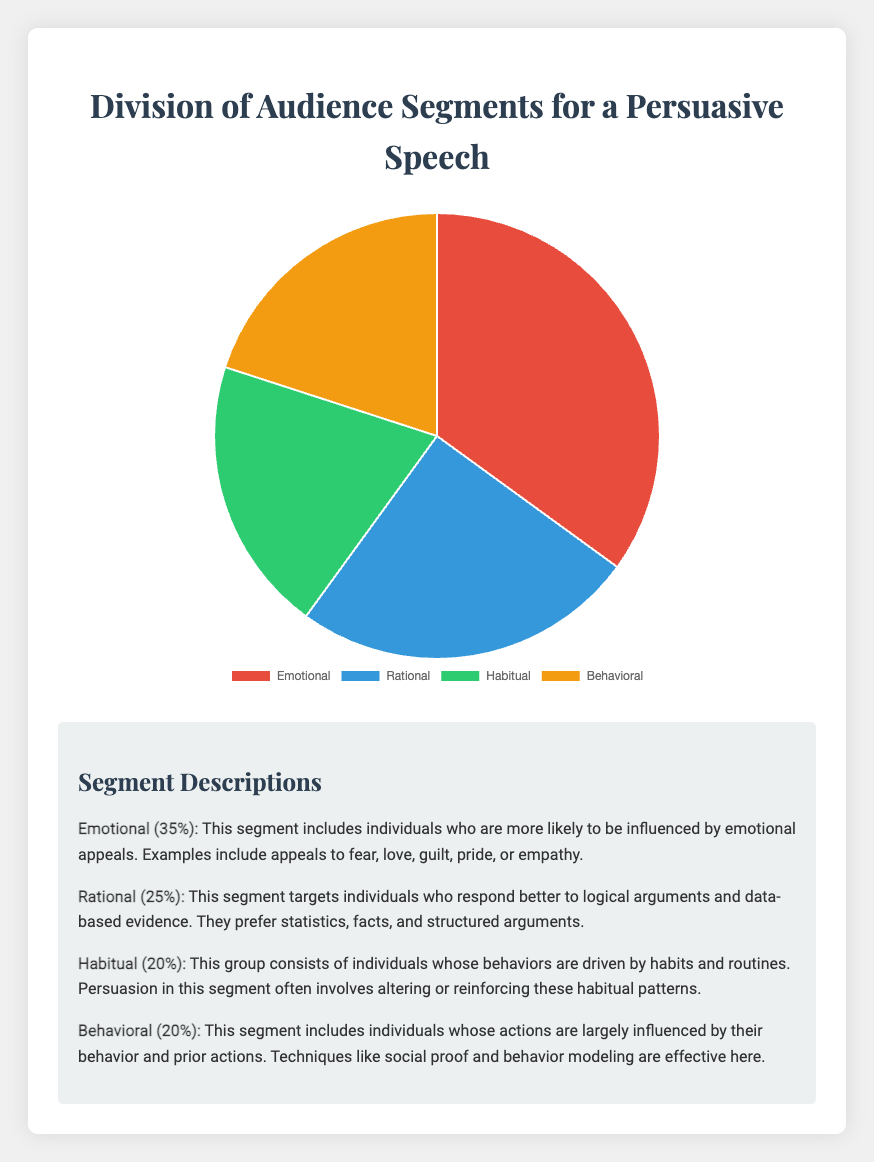What percentage of the audience is influenced by emotional appeals? The pie chart shows that the Emotional segment accounts for 35% of the audience.
Answer: 35% How much larger is the Emotional segment compared to the Rational segment? The Emotional segment is 35% while the Rational segment is 25%. Subtracting these percentages gives 35% - 25% = 10%.
Answer: 10% What's the combined percentage of the Habitual and Behavioral segments? The Habitual segment is 20% and the Behavioral segment is also 20%. Summing these gives 20% + 20% = 40%.
Answer: 40% Rank the segments from the largest to the smallest based on their percentages. The segments have the following percentages: Emotional (35%), Rational (25%), Habitual (20%), Behavioral (20%). Ranking these from largest to smallest gives: Emotional, Rational, Habitual, Behavioral.
Answer: Emotional, Rational, Habitual, Behavioral Which segment is tied in percentage and what is their combined share of the audience? The Habitual and Behavioral segments both account for 20% each. Their combined share is 20% + 20% = 40%.
Answer: Habitual and Behavioral, 40% What is the smallest segment in the pie chart, and what fraction of the pie chart do they represent? The smallest segments are Habitual and Behavioral, both at 20%. These segments each represent one-fifth (20%) of the pie chart.
Answer: Habitual and Behavioral, one-fifth Compare the visual representation of the Emotional and Behavioral segments. Which one is larger, and by how much? The Emotional segment is 35%, and the Behavioral segment is 20%. The difference is 35% - 20% = 15%. Visually, the red section (Emotional) is larger by 15%.
Answer: Emotional, 15% What are the visual colors associated with the Rational and Habitual segments? According to the colors used in the pie chart, the Rational segment is represented in blue, while the Habitual segment is in green.
Answer: Blue, Green Identify which segment or segments have the same percentage and explain why this might be important. The Habitual and Behavioral segments both have the same percentage of 20%. This is important as it indicates that both habitual cues and prior behavior patterns have an equal influence on the audience, which suggests that strategies targeting routine actions and previous behaviors might be equally effective.
Answer: Habitual and Behavioral, 20% 